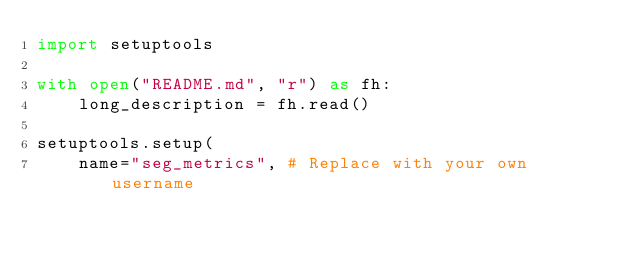Convert code to text. <code><loc_0><loc_0><loc_500><loc_500><_Python_>import setuptools

with open("README.md", "r") as fh:
    long_description = fh.read()

setuptools.setup(
    name="seg_metrics", # Replace with your own username</code> 